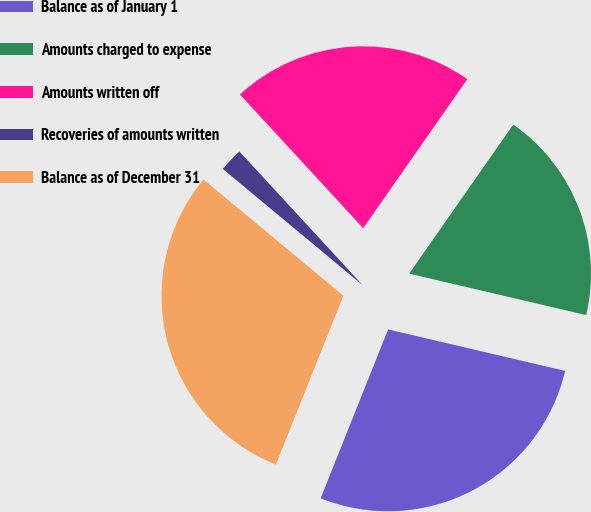Convert chart. <chart><loc_0><loc_0><loc_500><loc_500><pie_chart><fcel>Balance as of January 1<fcel>Amounts charged to expense<fcel>Amounts written off<fcel>Recoveries of amounts written<fcel>Balance as of December 31<nl><fcel>27.39%<fcel>18.96%<fcel>21.56%<fcel>2.11%<fcel>29.99%<nl></chart> 